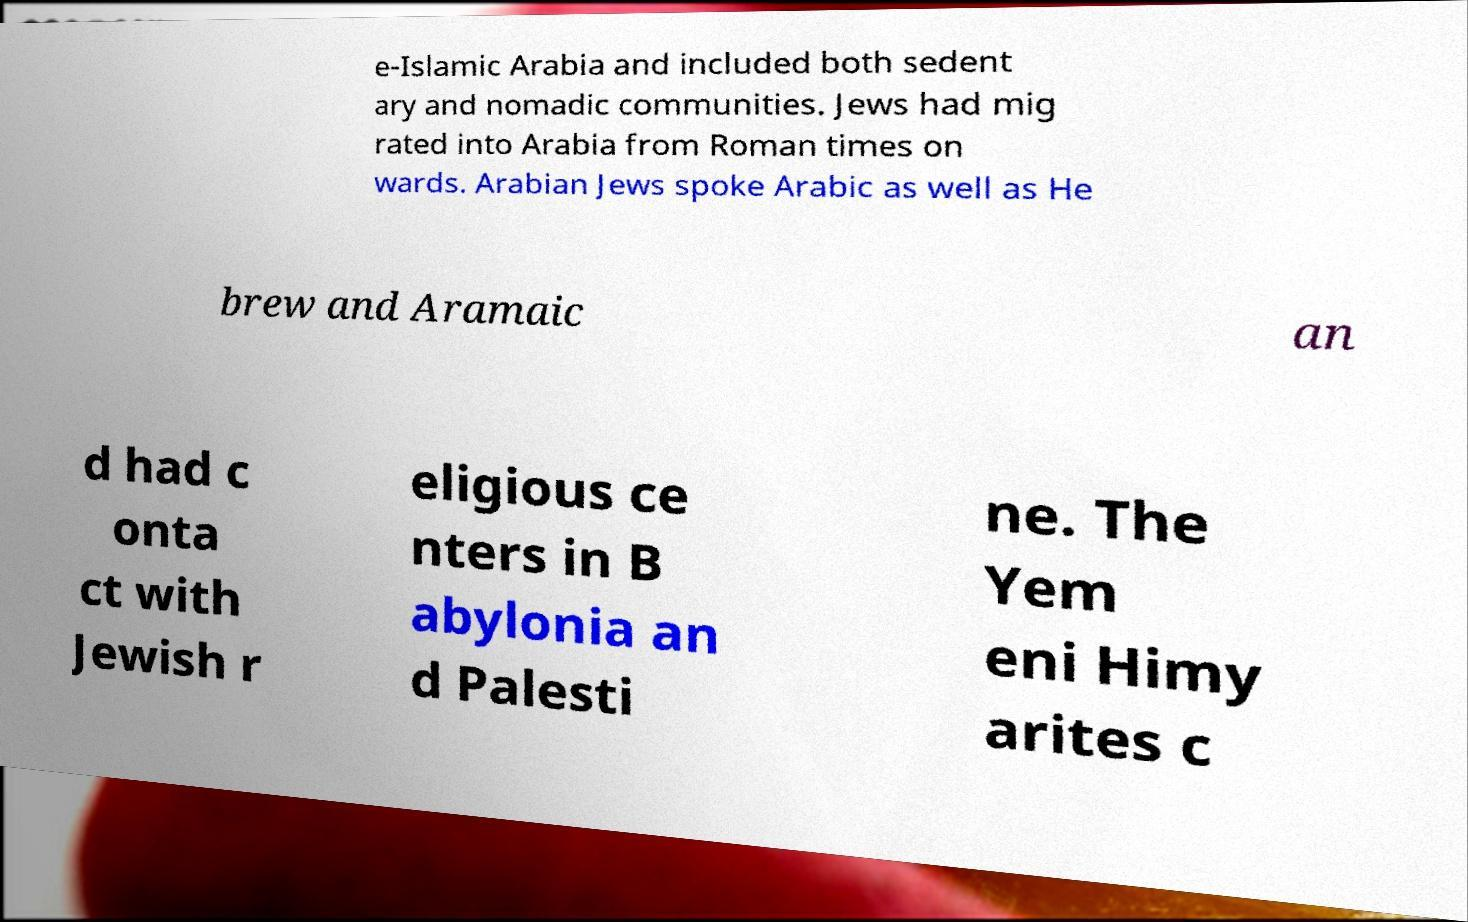Can you accurately transcribe the text from the provided image for me? e-Islamic Arabia and included both sedent ary and nomadic communities. Jews had mig rated into Arabia from Roman times on wards. Arabian Jews spoke Arabic as well as He brew and Aramaic an d had c onta ct with Jewish r eligious ce nters in B abylonia an d Palesti ne. The Yem eni Himy arites c 